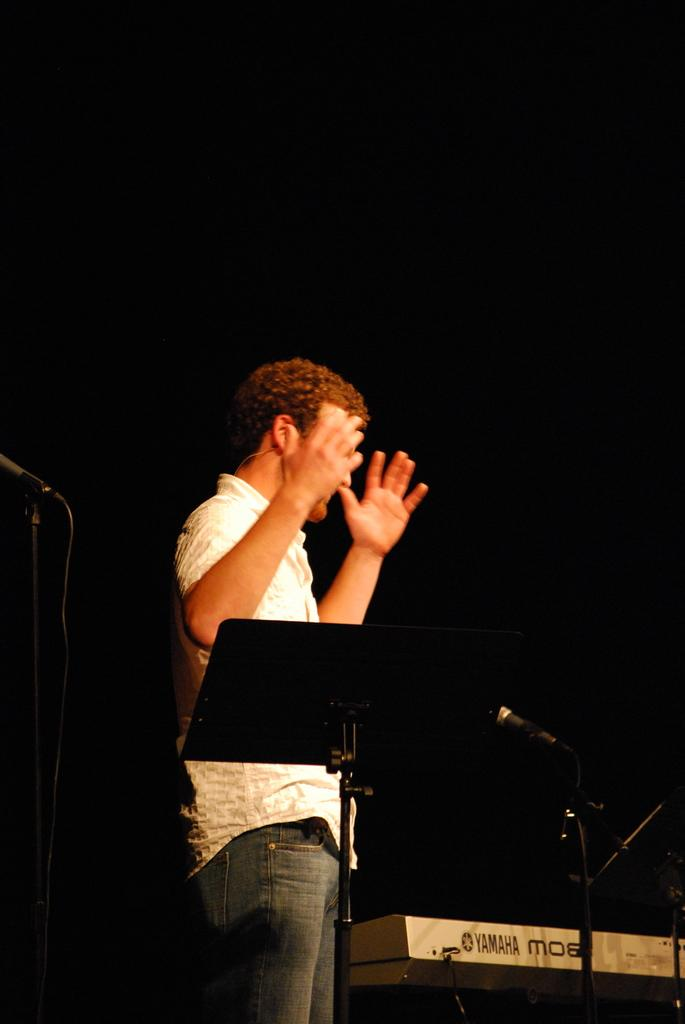Who or what is present in the image? There is a person in the image. What is the person doing in the image? The person is standing. What objects are near the person in the image? There is a microphone and a book stand beside the person. How many babies are crawling on the floor in the image? There are no babies present in the image. What type of net is being used to catch the cannon in the image? There is no net or cannon present in the image. 